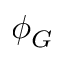Convert formula to latex. <formula><loc_0><loc_0><loc_500><loc_500>\phi _ { G }</formula> 